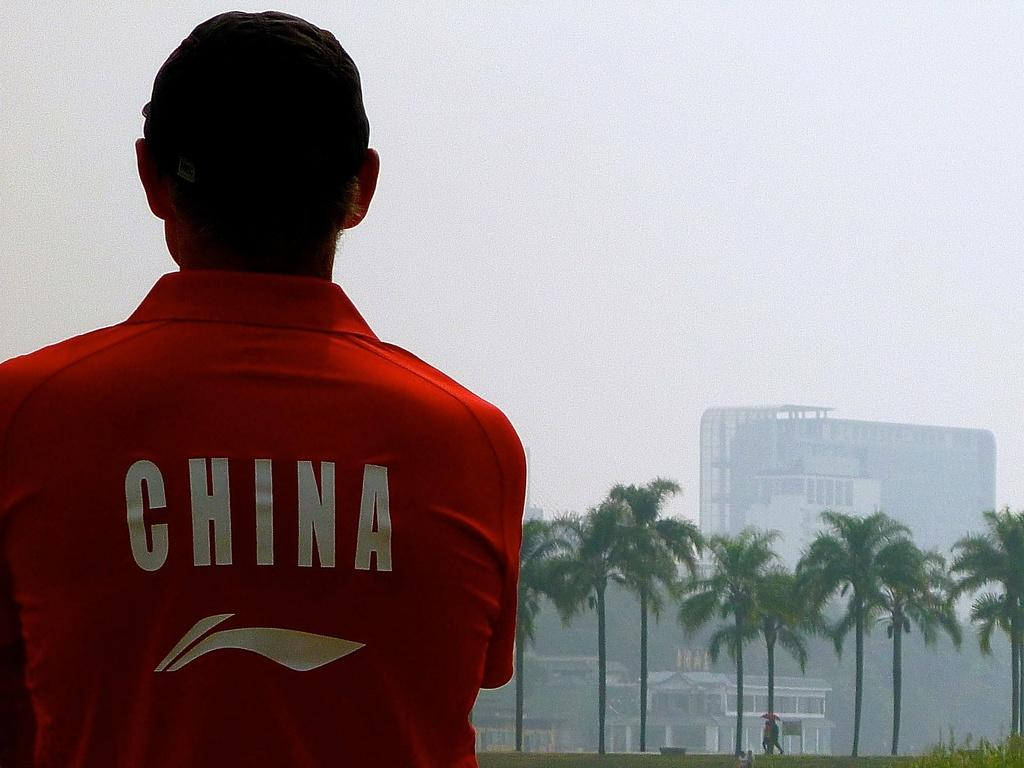<image>
Summarize the visual content of the image. A man is wearing a red shirt that says China on the back. 